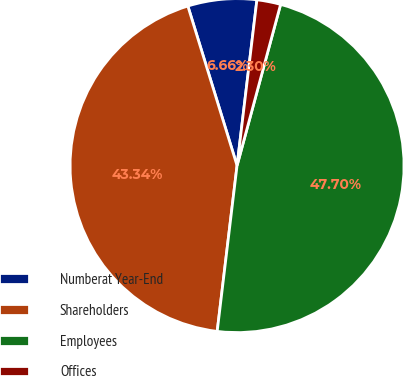Convert chart to OTSL. <chart><loc_0><loc_0><loc_500><loc_500><pie_chart><fcel>Numberat Year-End<fcel>Shareholders<fcel>Employees<fcel>Offices<nl><fcel>6.66%<fcel>43.34%<fcel>47.7%<fcel>2.3%<nl></chart> 